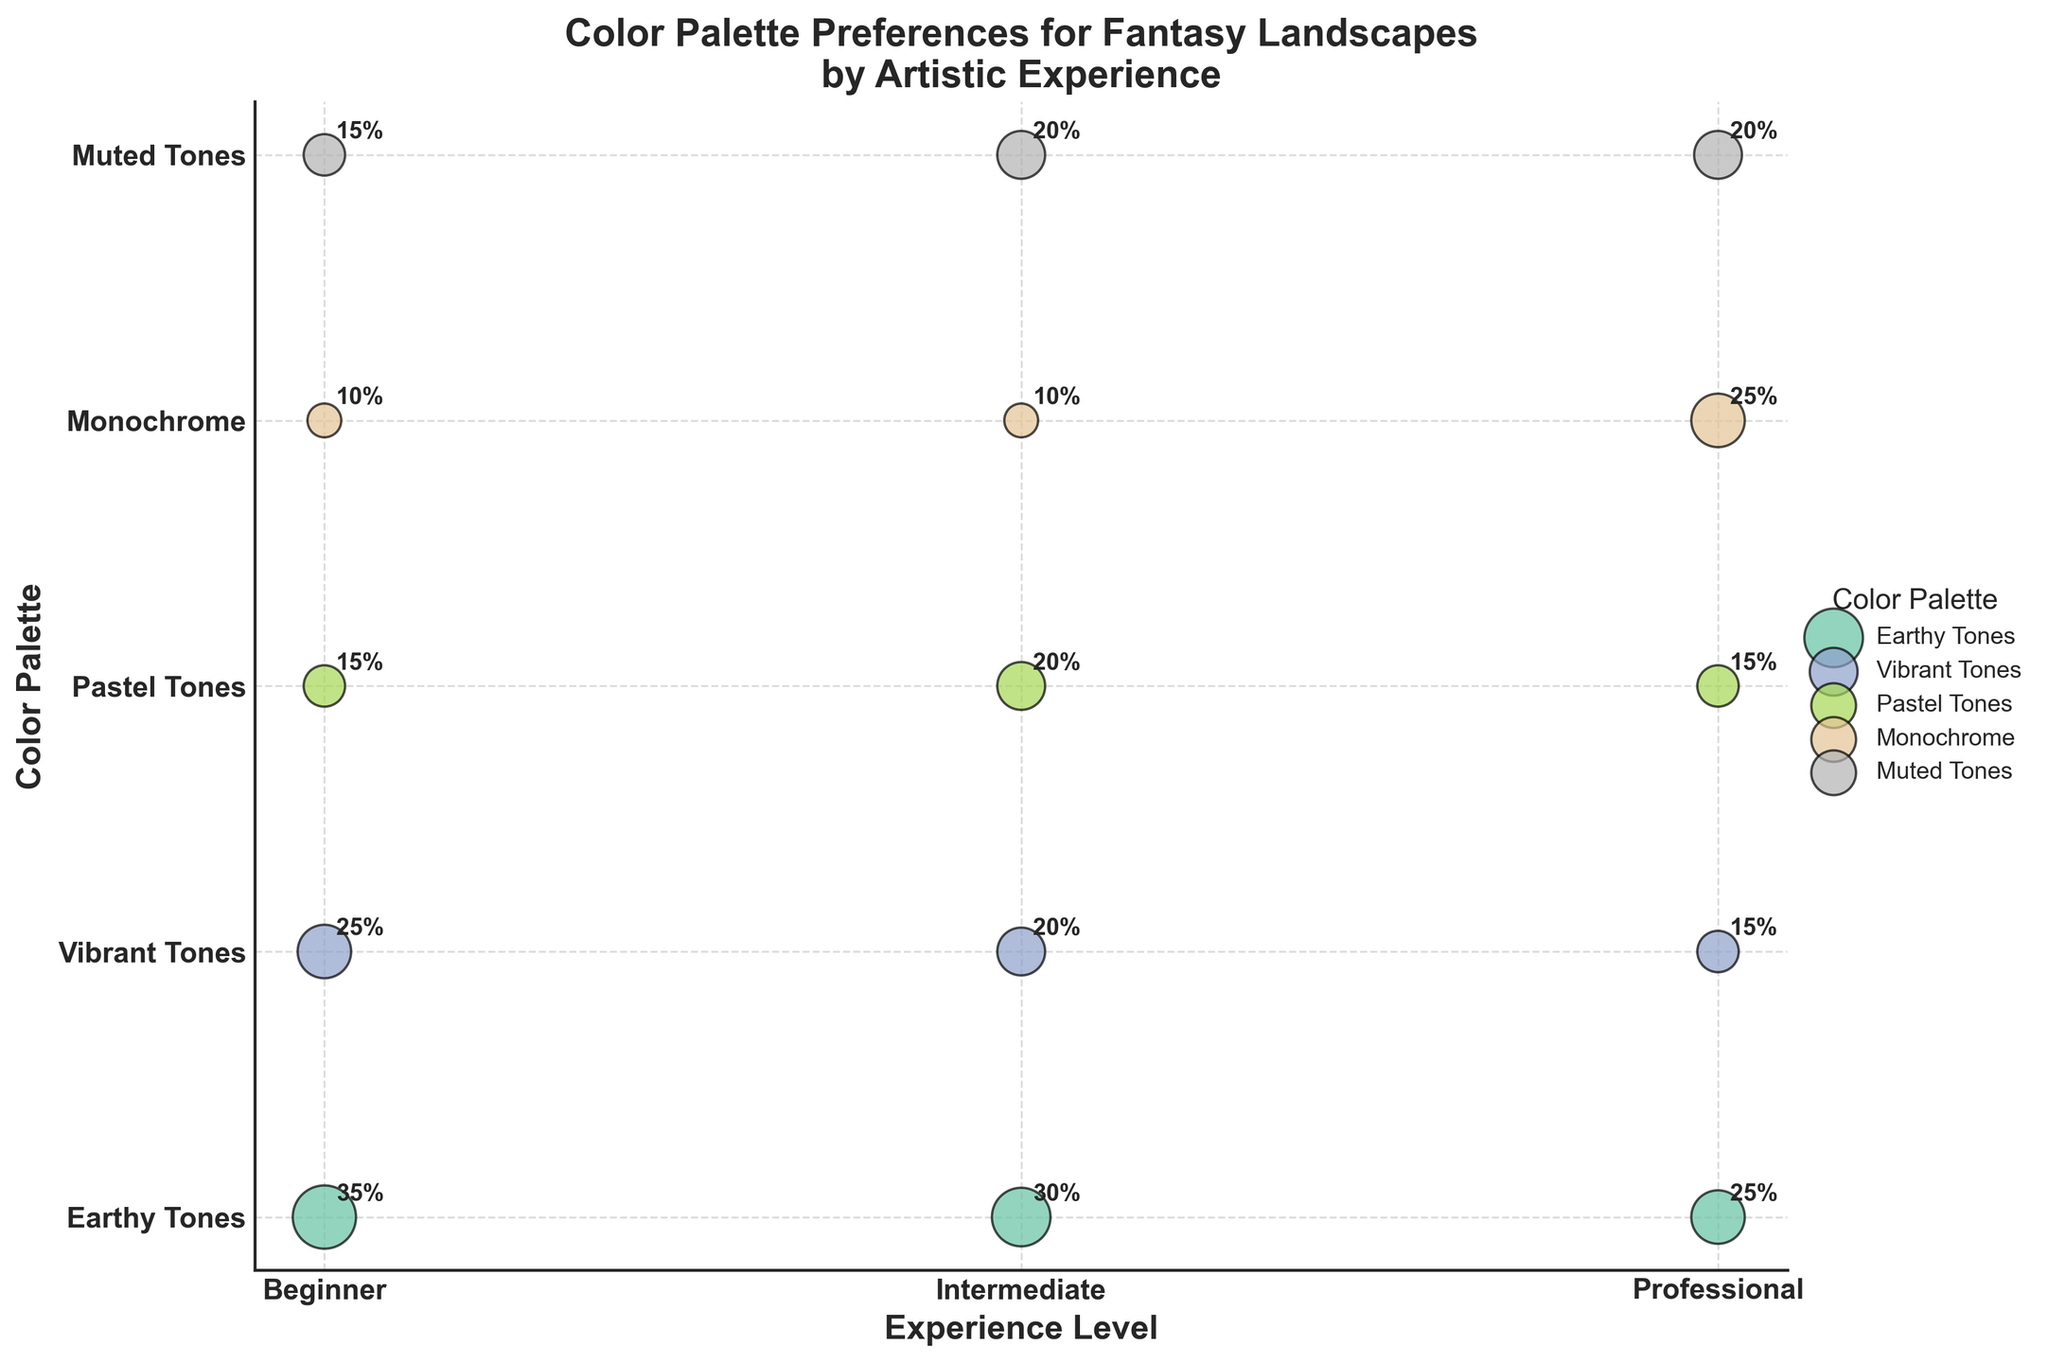What is the title of the figure? The title of the figure is positioned prominently at the top of the plot and is textually represented.
Answer: Color Palette Preferences for Fantasy Landscapes by Artistic Experience Which color palette does the 'Beginner' group prefer the most? The y-axis lists the color palettes, and when compared with the 'Beginner' group along the x-axis, the largest bubble size indicates the most preferred palette.
Answer: Earthy Tones How does the preference for 'Monochrome' palettes change with experience level? Observing the bubbles horizontally across the same y-coordinate, representing ‘Monochrome’, one can see the relative sizes of bubbles for different experience levels.
Answer: Increases with experience (10% for Beginners and Intermediates, 25% for Professionals) Which color palette has an equal preference between 'Intermediate' and 'Professional' artists? Locate bubbles with equal size at different x-coordinates but identical y-coordinates, representing the same color palette for both experience levels.
Answer: Pastel Tones and Muted Tones (20%) What is the total preference percentage for 'Vibrant Tones' across all experience levels? Add up the size of the bubbles for 'Vibrant Tones' (second y-coordinate from the bottom) horizontally across all experience levels.
Answer: 25 + 20 + 15 = 60% Which experience level group shows the least enthusiasm for 'Muted Tones'? Compare sizes of the bubbles corresponding to 'Muted Tones' (top y-coordinate) for each experience level.
Answer: Beginner and Professional (15%) Among 'Professional' artists, is there a certain color palette that stands out in preference compared to others? Compare the sizes of bubbles vertically under 'Professional' at the same x-coordinate to discern any standout preferences.
Answer: Monochrome (25%) What pattern do you observe for 'Earthy Tones’ across different experience levels? Track the bubble size for 'Earthy Tones' (bottom y-coordinate) across all experience levels in a horizontal line to identify trends.
Answer: Preferences decrease with experience level from 35% to 30% to 25% Is the preferred color palette for 'Intermediate' artists more evenly distributed compared to 'Professional' artists? Compare the uniformity of bubble sizes across different color palettes for both 'Intermediate' and 'Professional' columns.
Answer: Yes, it is more evenly distributed In which experience level group is the preference for 'Pastel Tones' notably different from the preference for 'Earthy Tones'? Compare the size difference vertically between 'Pastel Tones' and 'Earthy Tones' for each experience level group.
Answer: Beginners (20% difference: 35% for Earthy Tones, 15% for Pastel Tones) 